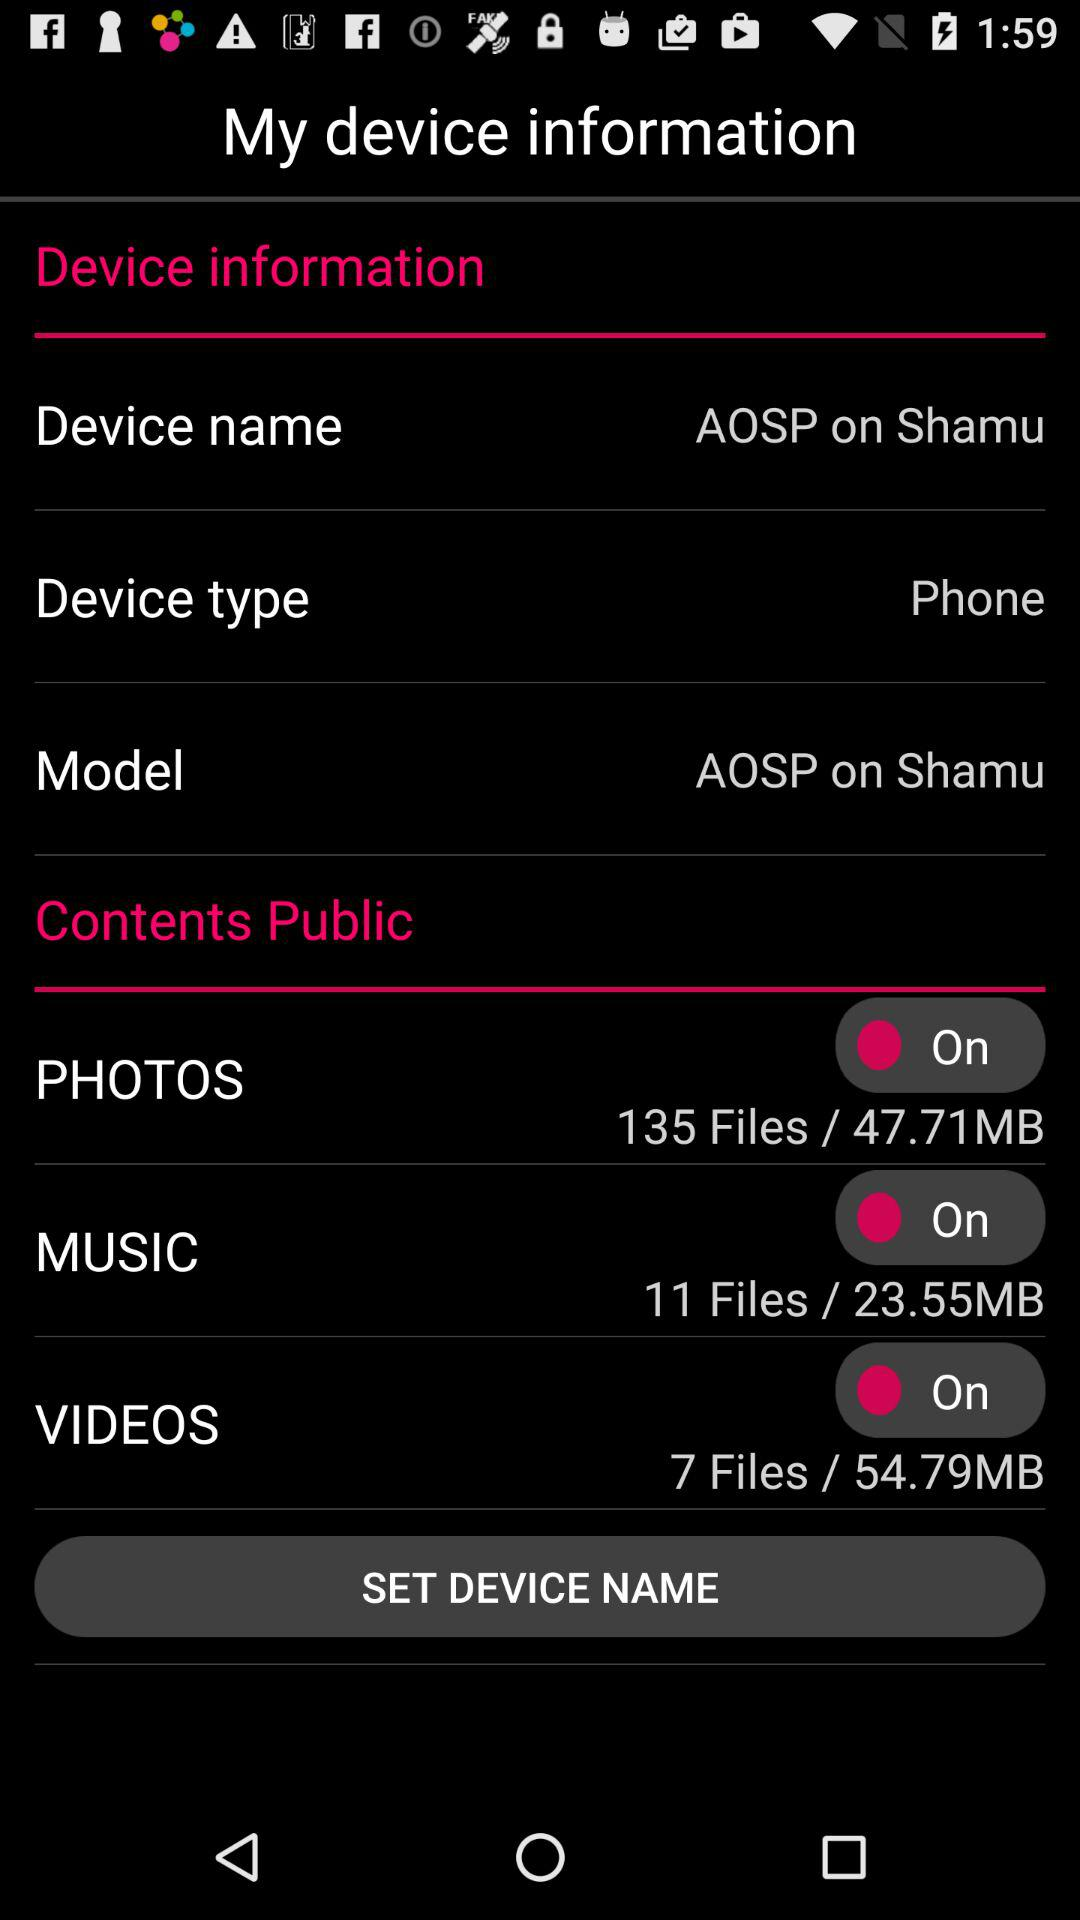What is the device name?
When the provided information is insufficient, respond with <no answer>. <no answer> 